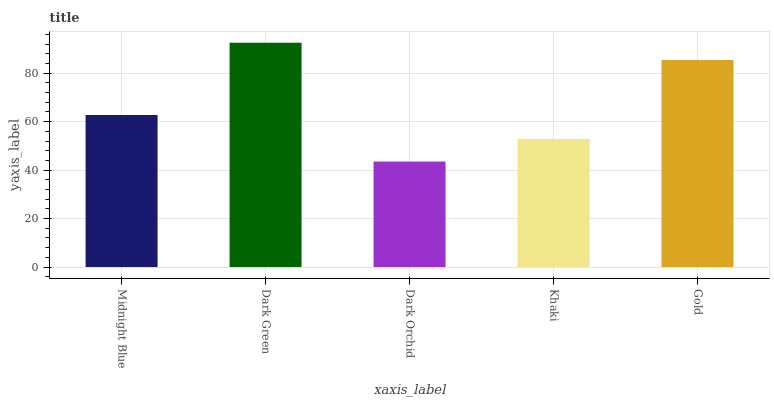Is Dark Orchid the minimum?
Answer yes or no. Yes. Is Dark Green the maximum?
Answer yes or no. Yes. Is Dark Green the minimum?
Answer yes or no. No. Is Dark Orchid the maximum?
Answer yes or no. No. Is Dark Green greater than Dark Orchid?
Answer yes or no. Yes. Is Dark Orchid less than Dark Green?
Answer yes or no. Yes. Is Dark Orchid greater than Dark Green?
Answer yes or no. No. Is Dark Green less than Dark Orchid?
Answer yes or no. No. Is Midnight Blue the high median?
Answer yes or no. Yes. Is Midnight Blue the low median?
Answer yes or no. Yes. Is Gold the high median?
Answer yes or no. No. Is Dark Green the low median?
Answer yes or no. No. 